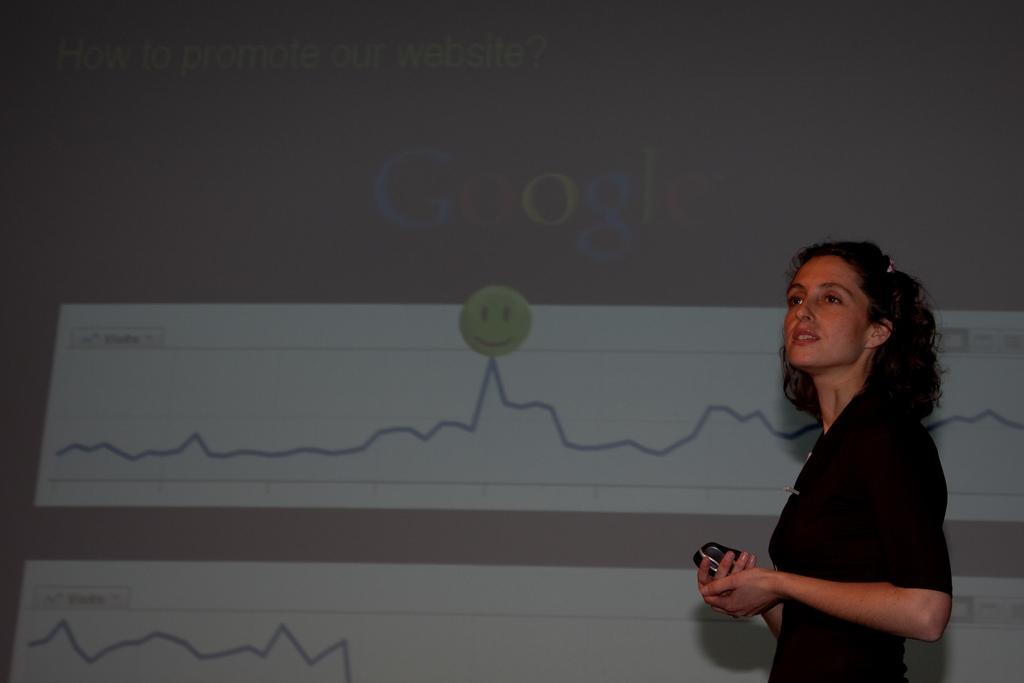Can you describe this image briefly? In the image there is a woman, she is giving a seminar and she is holding a gadget in her hands, behind the woman there is a seminar and it is displaying some pictures. 